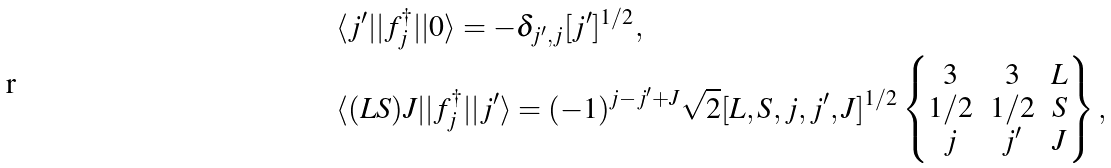Convert formula to latex. <formula><loc_0><loc_0><loc_500><loc_500>& \langle j ^ { \prime } | | f _ { j } ^ { \dagger } | | 0 \rangle = - \delta _ { j ^ { \prime } , j } [ j ^ { \prime } ] ^ { 1 / 2 } , \\ & \langle ( L S ) J | | f _ { j } ^ { \dagger } | | j ^ { \prime } \rangle = ( - 1 ) ^ { j - j ^ { \prime } + J } \sqrt { 2 } [ L , S , j , j ^ { \prime } , J ] ^ { 1 / 2 } \begin{Bmatrix} 3 & 3 & L \\ 1 / 2 & 1 / 2 & S \\ j & j ^ { \prime } & J \end{Bmatrix} ,</formula> 